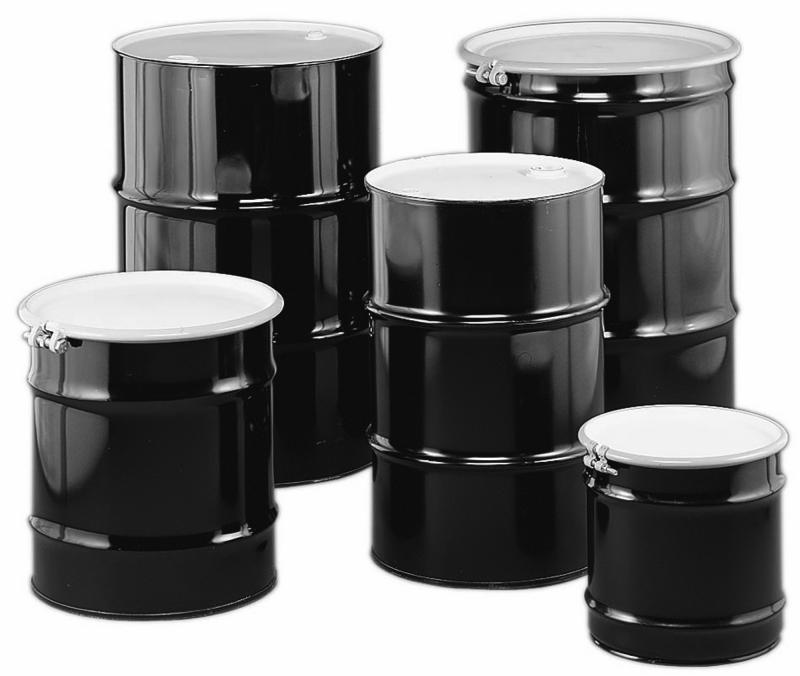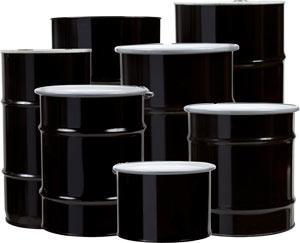The first image is the image on the left, the second image is the image on the right. For the images shown, is this caption "The image on the right has a single canister while the image on the left has six." true? Answer yes or no. No. The first image is the image on the left, the second image is the image on the right. Examine the images to the left and right. Is the description "The right image contains exactly one black barrel." accurate? Answer yes or no. No. 